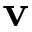<formula> <loc_0><loc_0><loc_500><loc_500>v</formula> 